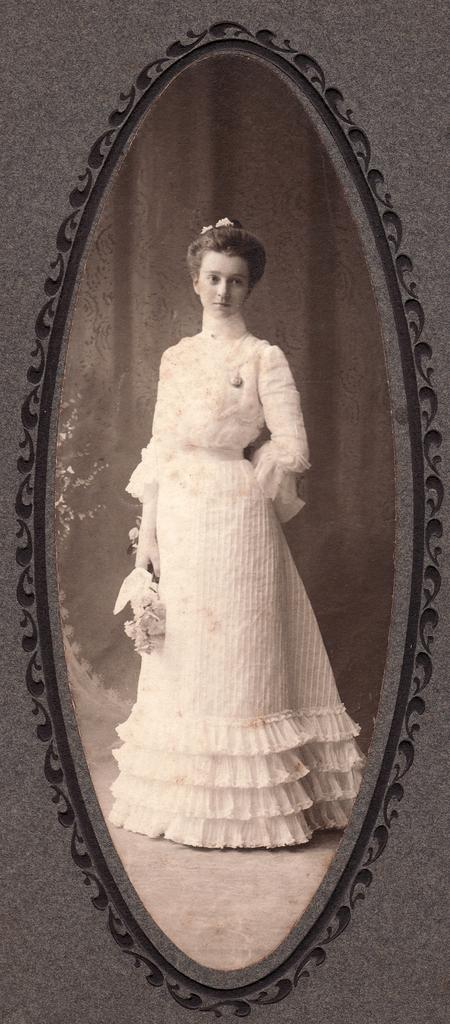What is inside the photo frame in the image? The photo frame contains an image. Can you describe the subject of the image? There is a woman in the image. What is the woman wearing? The woman is wearing a white dress. What is the woman doing in the image? The woman is standing. What can be seen in the background of the image? There is a curtain in the background of the image. How many balloons are floating around the woman in the image? There are no balloons present in the image; it only features a woman standing in front of a curtain. Is the woman sinking in quicksand in the image? There is no quicksand present in the image, and the woman is standing, not sinking. 